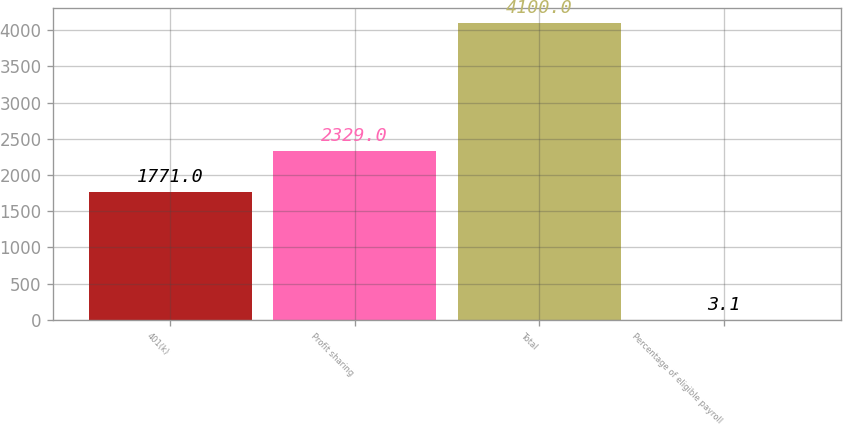Convert chart. <chart><loc_0><loc_0><loc_500><loc_500><bar_chart><fcel>401(k)<fcel>Profit sharing<fcel>Total<fcel>Percentage of eligible payroll<nl><fcel>1771<fcel>2329<fcel>4100<fcel>3.1<nl></chart> 